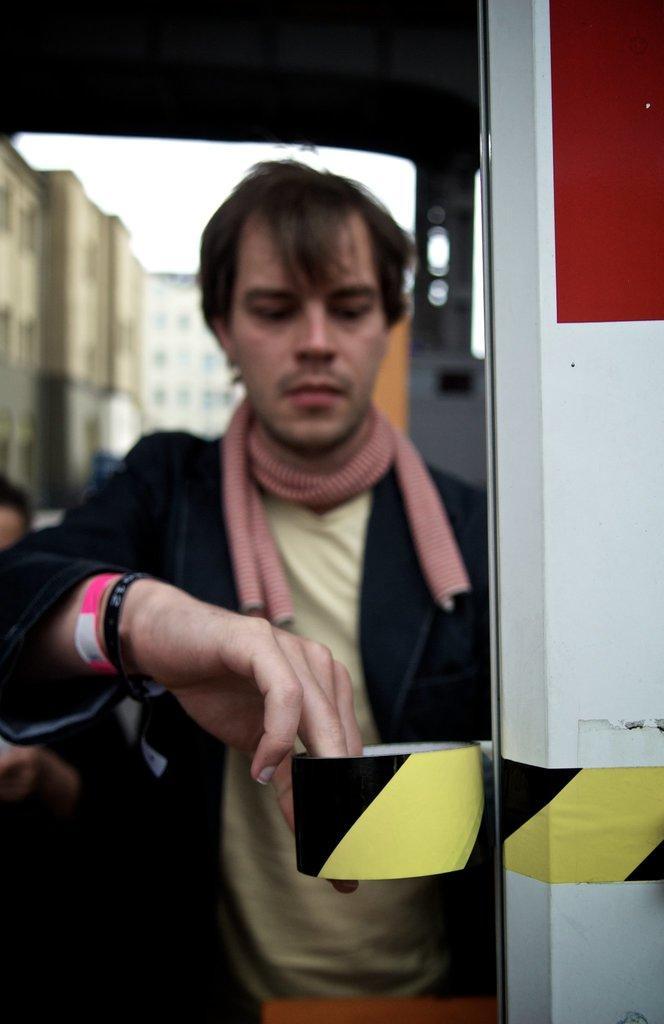Could you give a brief overview of what you see in this image? In this image we can see one man standing and holding one object in a vehicle. There is another person standing, some buildings backside of the man, one object on the surface and at the top there is the sky. 